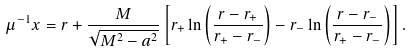Convert formula to latex. <formula><loc_0><loc_0><loc_500><loc_500>\mu ^ { - 1 } x = r + \frac { M } { \sqrt { M ^ { 2 } - a ^ { 2 } } } \left [ r _ { + } \ln \left ( \frac { r - r _ { + } } { r _ { + } - r _ { - } } \right ) - r _ { - } \ln \left ( \frac { r - r _ { - } } { r _ { + } - r _ { - } } \right ) \right ] .</formula> 